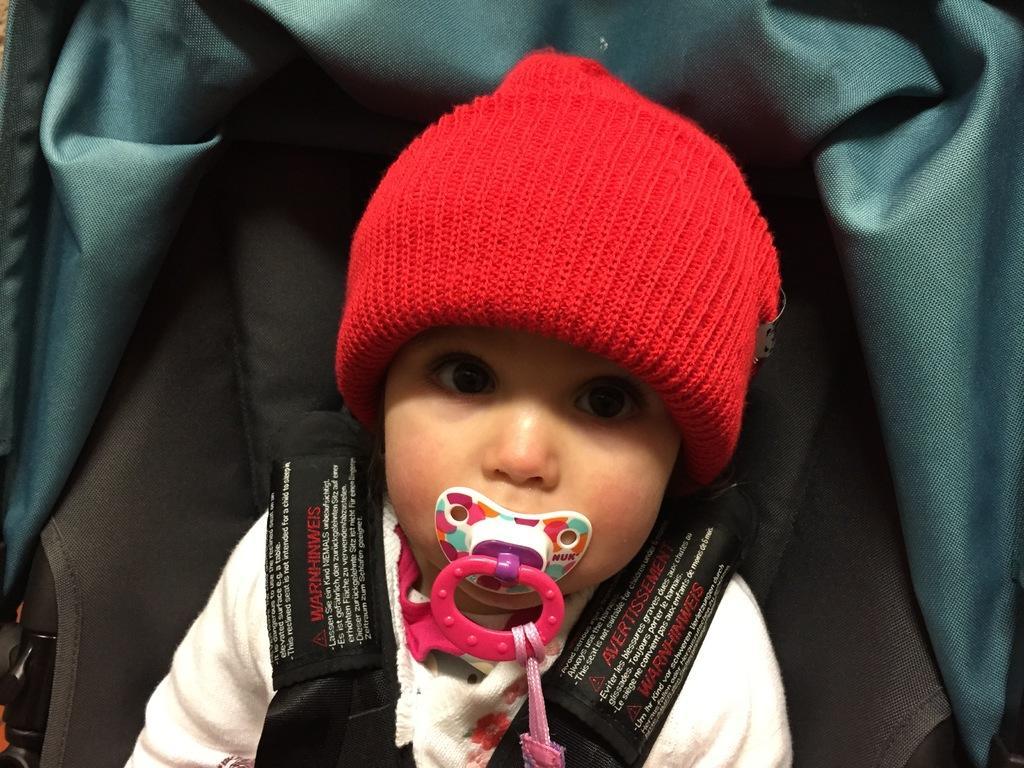How would you summarize this image in a sentence or two? In this picture we can see a baby and this baby is wearing a cap, here we can see an object in mouth and in the background we can see a chair. 